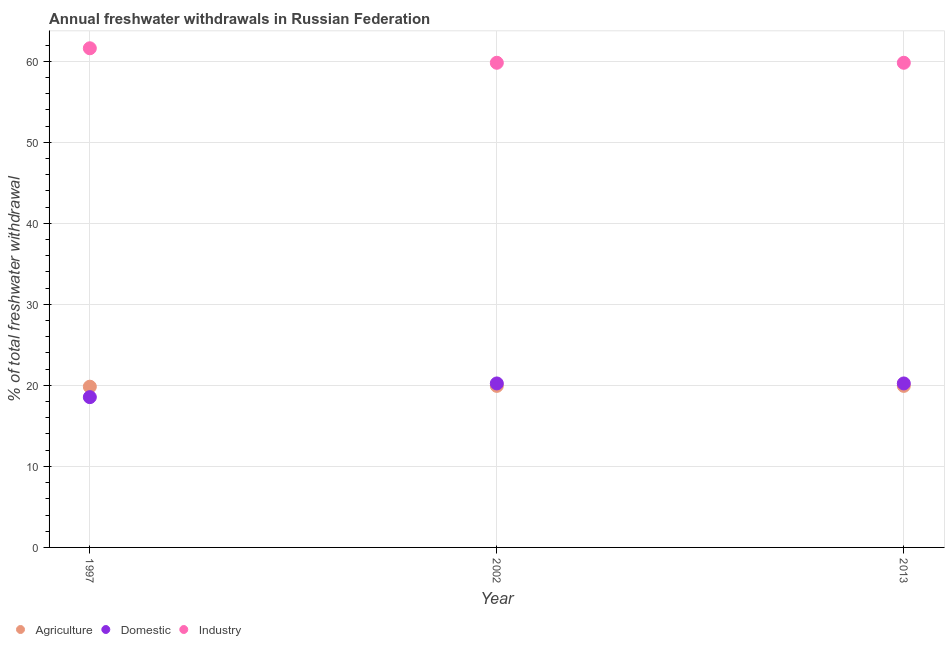What is the percentage of freshwater withdrawal for agriculture in 2013?
Offer a very short reply. 19.94. Across all years, what is the maximum percentage of freshwater withdrawal for agriculture?
Make the answer very short. 19.94. Across all years, what is the minimum percentage of freshwater withdrawal for agriculture?
Provide a succinct answer. 19.84. In which year was the percentage of freshwater withdrawal for domestic purposes minimum?
Your response must be concise. 1997. What is the total percentage of freshwater withdrawal for industry in the graph?
Give a very brief answer. 181.25. What is the difference between the percentage of freshwater withdrawal for agriculture in 2002 and that in 2013?
Keep it short and to the point. 0. What is the difference between the percentage of freshwater withdrawal for domestic purposes in 1997 and the percentage of freshwater withdrawal for agriculture in 2013?
Provide a succinct answer. -1.39. What is the average percentage of freshwater withdrawal for industry per year?
Keep it short and to the point. 60.42. In the year 2002, what is the difference between the percentage of freshwater withdrawal for industry and percentage of freshwater withdrawal for agriculture?
Give a very brief answer. 39.88. In how many years, is the percentage of freshwater withdrawal for domestic purposes greater than 18 %?
Your response must be concise. 3. What is the ratio of the percentage of freshwater withdrawal for domestic purposes in 1997 to that in 2013?
Offer a very short reply. 0.92. What is the difference between the highest and the second highest percentage of freshwater withdrawal for agriculture?
Keep it short and to the point. 0. What is the difference between the highest and the lowest percentage of freshwater withdrawal for domestic purposes?
Your response must be concise. 1.69. Is it the case that in every year, the sum of the percentage of freshwater withdrawal for agriculture and percentage of freshwater withdrawal for domestic purposes is greater than the percentage of freshwater withdrawal for industry?
Your answer should be compact. No. Is the percentage of freshwater withdrawal for agriculture strictly greater than the percentage of freshwater withdrawal for domestic purposes over the years?
Offer a very short reply. No. Is the percentage of freshwater withdrawal for agriculture strictly less than the percentage of freshwater withdrawal for industry over the years?
Ensure brevity in your answer.  Yes. How many dotlines are there?
Offer a terse response. 3. Are the values on the major ticks of Y-axis written in scientific E-notation?
Keep it short and to the point. No. What is the title of the graph?
Keep it short and to the point. Annual freshwater withdrawals in Russian Federation. What is the label or title of the X-axis?
Your answer should be very brief. Year. What is the label or title of the Y-axis?
Your response must be concise. % of total freshwater withdrawal. What is the % of total freshwater withdrawal of Agriculture in 1997?
Offer a terse response. 19.84. What is the % of total freshwater withdrawal of Domestic in 1997?
Offer a terse response. 18.55. What is the % of total freshwater withdrawal in Industry in 1997?
Offer a very short reply. 61.61. What is the % of total freshwater withdrawal of Agriculture in 2002?
Your answer should be very brief. 19.94. What is the % of total freshwater withdrawal in Domestic in 2002?
Offer a very short reply. 20.24. What is the % of total freshwater withdrawal of Industry in 2002?
Your answer should be very brief. 59.82. What is the % of total freshwater withdrawal in Agriculture in 2013?
Offer a terse response. 19.94. What is the % of total freshwater withdrawal of Domestic in 2013?
Your answer should be very brief. 20.24. What is the % of total freshwater withdrawal in Industry in 2013?
Offer a terse response. 59.82. Across all years, what is the maximum % of total freshwater withdrawal of Agriculture?
Your response must be concise. 19.94. Across all years, what is the maximum % of total freshwater withdrawal in Domestic?
Ensure brevity in your answer.  20.24. Across all years, what is the maximum % of total freshwater withdrawal in Industry?
Your response must be concise. 61.61. Across all years, what is the minimum % of total freshwater withdrawal of Agriculture?
Offer a very short reply. 19.84. Across all years, what is the minimum % of total freshwater withdrawal of Domestic?
Make the answer very short. 18.55. Across all years, what is the minimum % of total freshwater withdrawal of Industry?
Your answer should be compact. 59.82. What is the total % of total freshwater withdrawal in Agriculture in the graph?
Keep it short and to the point. 59.72. What is the total % of total freshwater withdrawal in Domestic in the graph?
Provide a short and direct response. 59.03. What is the total % of total freshwater withdrawal of Industry in the graph?
Your response must be concise. 181.25. What is the difference between the % of total freshwater withdrawal of Domestic in 1997 and that in 2002?
Offer a terse response. -1.69. What is the difference between the % of total freshwater withdrawal in Industry in 1997 and that in 2002?
Offer a very short reply. 1.79. What is the difference between the % of total freshwater withdrawal of Domestic in 1997 and that in 2013?
Keep it short and to the point. -1.69. What is the difference between the % of total freshwater withdrawal in Industry in 1997 and that in 2013?
Offer a very short reply. 1.79. What is the difference between the % of total freshwater withdrawal in Agriculture in 2002 and that in 2013?
Give a very brief answer. 0. What is the difference between the % of total freshwater withdrawal of Domestic in 2002 and that in 2013?
Your answer should be very brief. 0. What is the difference between the % of total freshwater withdrawal in Agriculture in 1997 and the % of total freshwater withdrawal in Industry in 2002?
Provide a succinct answer. -39.98. What is the difference between the % of total freshwater withdrawal of Domestic in 1997 and the % of total freshwater withdrawal of Industry in 2002?
Offer a terse response. -41.27. What is the difference between the % of total freshwater withdrawal of Agriculture in 1997 and the % of total freshwater withdrawal of Domestic in 2013?
Provide a short and direct response. -0.4. What is the difference between the % of total freshwater withdrawal in Agriculture in 1997 and the % of total freshwater withdrawal in Industry in 2013?
Provide a short and direct response. -39.98. What is the difference between the % of total freshwater withdrawal in Domestic in 1997 and the % of total freshwater withdrawal in Industry in 2013?
Make the answer very short. -41.27. What is the difference between the % of total freshwater withdrawal in Agriculture in 2002 and the % of total freshwater withdrawal in Industry in 2013?
Make the answer very short. -39.88. What is the difference between the % of total freshwater withdrawal in Domestic in 2002 and the % of total freshwater withdrawal in Industry in 2013?
Provide a succinct answer. -39.58. What is the average % of total freshwater withdrawal in Agriculture per year?
Ensure brevity in your answer.  19.91. What is the average % of total freshwater withdrawal of Domestic per year?
Ensure brevity in your answer.  19.68. What is the average % of total freshwater withdrawal of Industry per year?
Keep it short and to the point. 60.42. In the year 1997, what is the difference between the % of total freshwater withdrawal of Agriculture and % of total freshwater withdrawal of Domestic?
Make the answer very short. 1.29. In the year 1997, what is the difference between the % of total freshwater withdrawal of Agriculture and % of total freshwater withdrawal of Industry?
Give a very brief answer. -41.77. In the year 1997, what is the difference between the % of total freshwater withdrawal in Domestic and % of total freshwater withdrawal in Industry?
Offer a terse response. -43.06. In the year 2002, what is the difference between the % of total freshwater withdrawal of Agriculture and % of total freshwater withdrawal of Domestic?
Provide a succinct answer. -0.3. In the year 2002, what is the difference between the % of total freshwater withdrawal in Agriculture and % of total freshwater withdrawal in Industry?
Keep it short and to the point. -39.88. In the year 2002, what is the difference between the % of total freshwater withdrawal of Domestic and % of total freshwater withdrawal of Industry?
Your answer should be very brief. -39.58. In the year 2013, what is the difference between the % of total freshwater withdrawal in Agriculture and % of total freshwater withdrawal in Industry?
Your answer should be very brief. -39.88. In the year 2013, what is the difference between the % of total freshwater withdrawal in Domestic and % of total freshwater withdrawal in Industry?
Your response must be concise. -39.58. What is the ratio of the % of total freshwater withdrawal in Domestic in 1997 to that in 2002?
Provide a succinct answer. 0.92. What is the ratio of the % of total freshwater withdrawal of Industry in 1997 to that in 2002?
Your response must be concise. 1.03. What is the ratio of the % of total freshwater withdrawal of Agriculture in 1997 to that in 2013?
Give a very brief answer. 0.99. What is the ratio of the % of total freshwater withdrawal in Domestic in 1997 to that in 2013?
Keep it short and to the point. 0.92. What is the ratio of the % of total freshwater withdrawal of Industry in 1997 to that in 2013?
Provide a short and direct response. 1.03. What is the difference between the highest and the second highest % of total freshwater withdrawal of Domestic?
Offer a very short reply. 0. What is the difference between the highest and the second highest % of total freshwater withdrawal of Industry?
Your response must be concise. 1.79. What is the difference between the highest and the lowest % of total freshwater withdrawal of Agriculture?
Give a very brief answer. 0.1. What is the difference between the highest and the lowest % of total freshwater withdrawal in Domestic?
Your answer should be compact. 1.69. What is the difference between the highest and the lowest % of total freshwater withdrawal of Industry?
Provide a short and direct response. 1.79. 